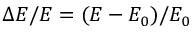<formula> <loc_0><loc_0><loc_500><loc_500>\Delta E / E = ( E - E _ { 0 } ) / E _ { 0 }</formula> 